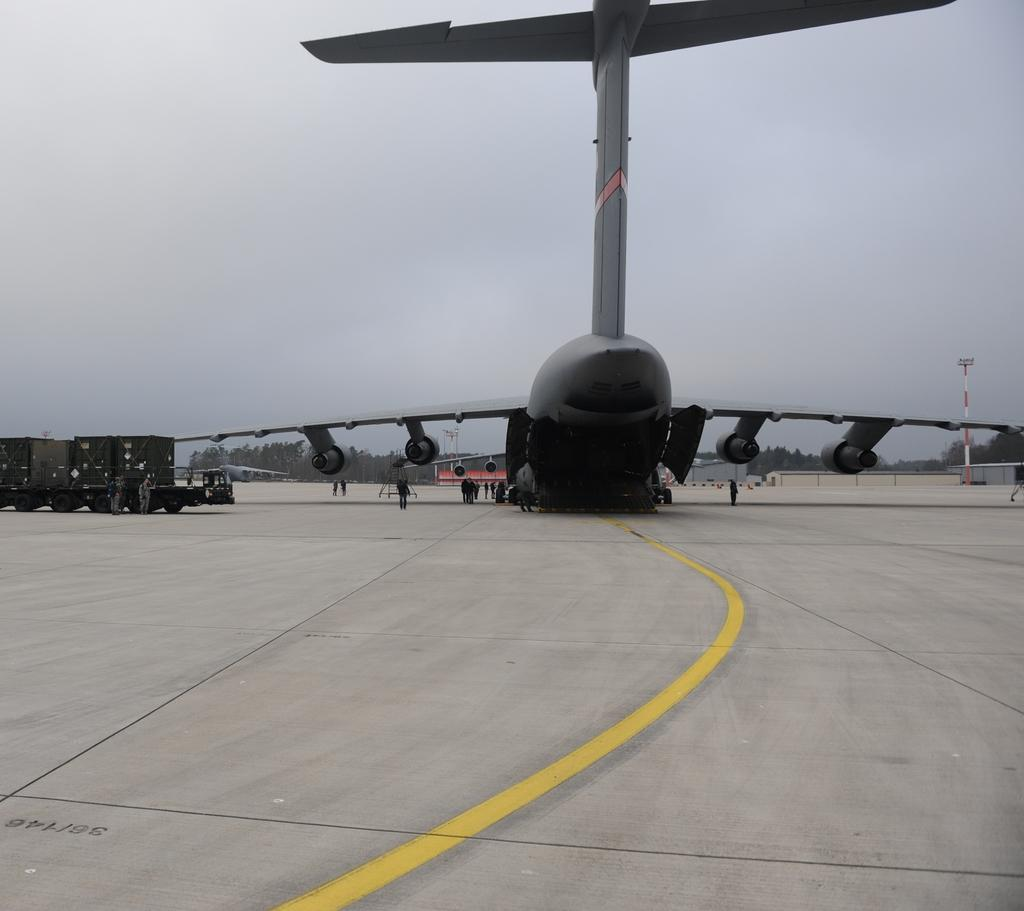What is the main subject of the image? The main subject of the image is an airplane. Where is the airplane located in the image? The airplane is in the center of the image. What can be seen on the ground in the image? There are persons on the runway. What is visible in the background of the image? Trees, sheds, and the sky are visible in the background of the image. How many deer can be seen in the image? There are no deer present in the image. What type of fight is taking place in the image? There is no fight depicted in the image; it features an airplane, persons on the runway, and background elements. 